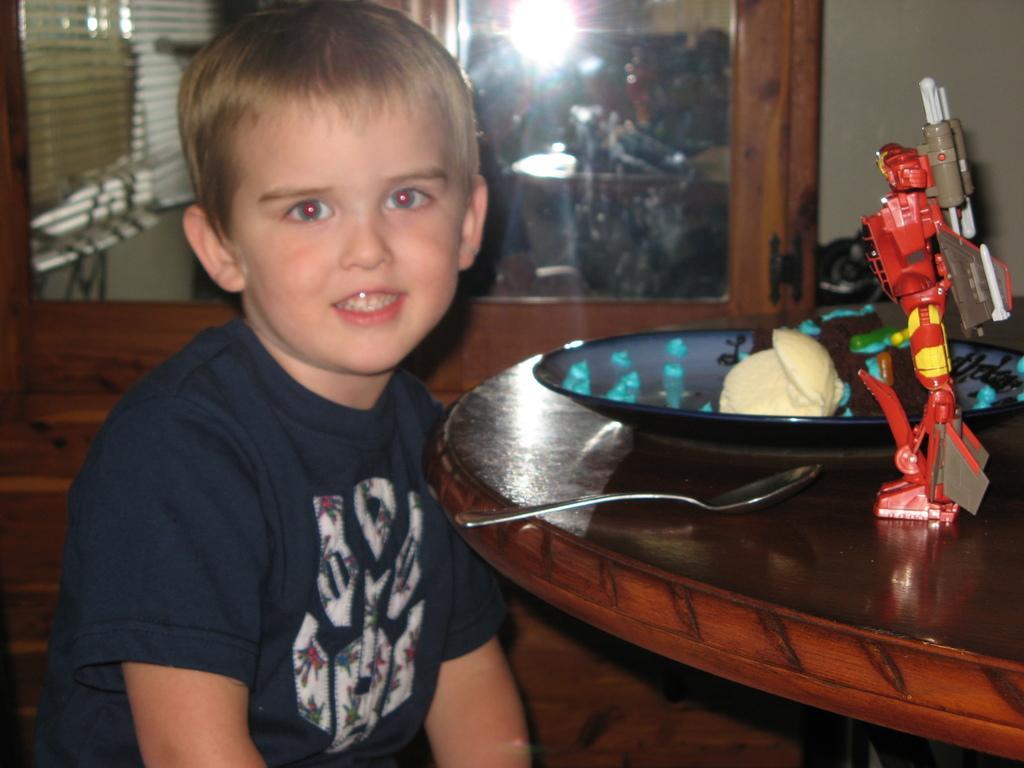Can you describe this image briefly? As we can see in the image there is a boy, and in front of him there is a table. On table there is a toy, bowl and spoon. 